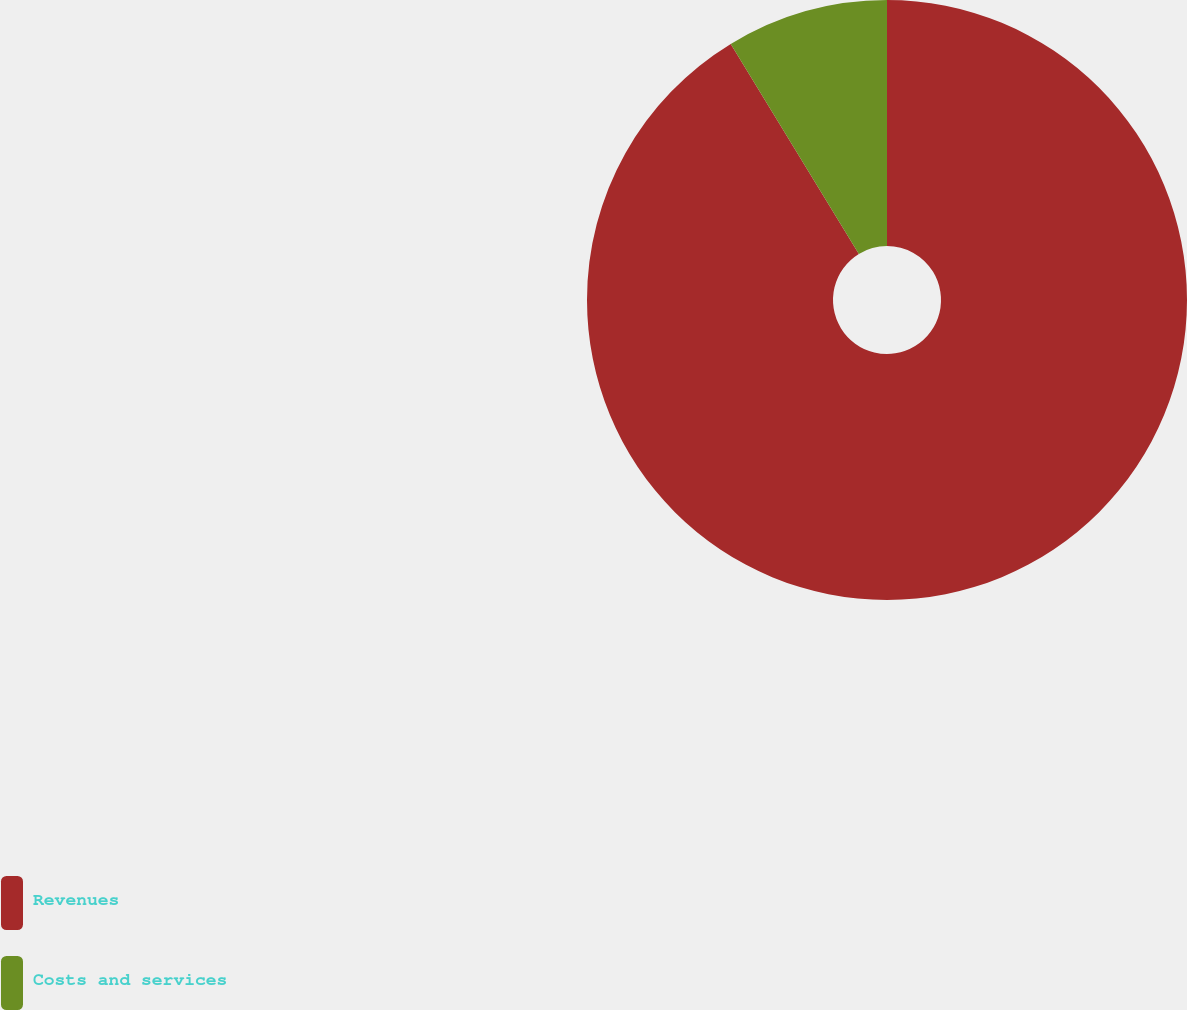Convert chart. <chart><loc_0><loc_0><loc_500><loc_500><pie_chart><fcel>Revenues<fcel>Costs and services<nl><fcel>91.28%<fcel>8.72%<nl></chart> 